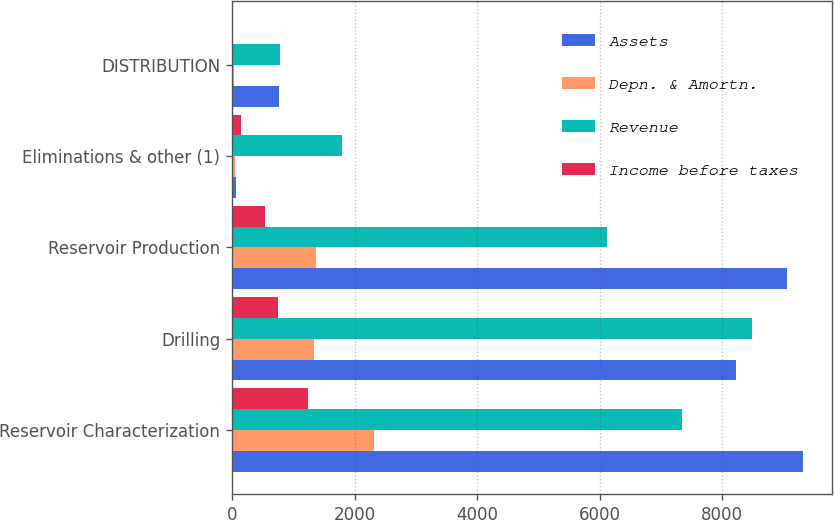<chart> <loc_0><loc_0><loc_500><loc_500><stacked_bar_chart><ecel><fcel>Reservoir Characterization<fcel>Drilling<fcel>Reservoir Production<fcel>Eliminations & other (1)<fcel>DISTRIBUTION<nl><fcel>Assets<fcel>9321<fcel>8230<fcel>9053<fcel>69<fcel>774<nl><fcel>Depn. & Amortn.<fcel>2321<fcel>1334<fcel>1368<fcel>48<fcel>29<nl><fcel>Revenue<fcel>7338<fcel>8490<fcel>6119<fcel>1801<fcel>780<nl><fcel>Income before taxes<fcel>1246<fcel>756<fcel>536<fcel>142<fcel>2<nl></chart> 